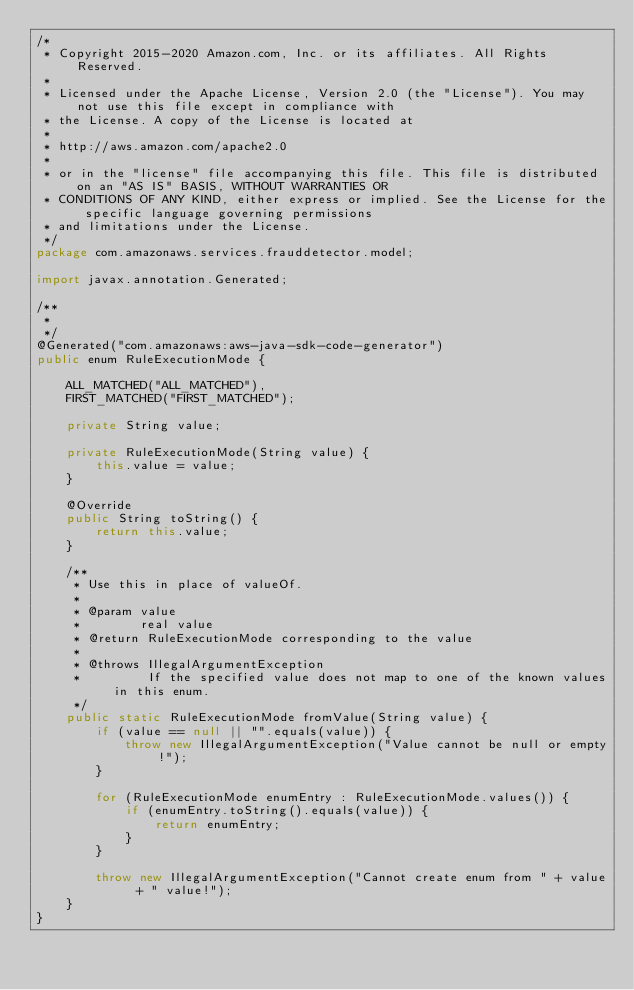Convert code to text. <code><loc_0><loc_0><loc_500><loc_500><_Java_>/*
 * Copyright 2015-2020 Amazon.com, Inc. or its affiliates. All Rights Reserved.
 * 
 * Licensed under the Apache License, Version 2.0 (the "License"). You may not use this file except in compliance with
 * the License. A copy of the License is located at
 * 
 * http://aws.amazon.com/apache2.0
 * 
 * or in the "license" file accompanying this file. This file is distributed on an "AS IS" BASIS, WITHOUT WARRANTIES OR
 * CONDITIONS OF ANY KIND, either express or implied. See the License for the specific language governing permissions
 * and limitations under the License.
 */
package com.amazonaws.services.frauddetector.model;

import javax.annotation.Generated;

/**
 * 
 */
@Generated("com.amazonaws:aws-java-sdk-code-generator")
public enum RuleExecutionMode {

    ALL_MATCHED("ALL_MATCHED"),
    FIRST_MATCHED("FIRST_MATCHED");

    private String value;

    private RuleExecutionMode(String value) {
        this.value = value;
    }

    @Override
    public String toString() {
        return this.value;
    }

    /**
     * Use this in place of valueOf.
     *
     * @param value
     *        real value
     * @return RuleExecutionMode corresponding to the value
     *
     * @throws IllegalArgumentException
     *         If the specified value does not map to one of the known values in this enum.
     */
    public static RuleExecutionMode fromValue(String value) {
        if (value == null || "".equals(value)) {
            throw new IllegalArgumentException("Value cannot be null or empty!");
        }

        for (RuleExecutionMode enumEntry : RuleExecutionMode.values()) {
            if (enumEntry.toString().equals(value)) {
                return enumEntry;
            }
        }

        throw new IllegalArgumentException("Cannot create enum from " + value + " value!");
    }
}
</code> 